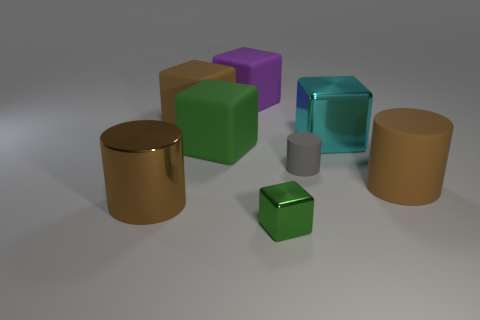Add 1 small gray matte objects. How many objects exist? 9 Subtract 5 cubes. How many cubes are left? 0 Subtract all rubber cubes. How many cubes are left? 2 Subtract all blocks. How many objects are left? 3 Add 6 small cylinders. How many small cylinders are left? 7 Add 7 matte blocks. How many matte blocks exist? 10 Subtract all brown cylinders. How many cylinders are left? 1 Subtract 0 cyan cylinders. How many objects are left? 8 Subtract all purple cubes. Subtract all gray cylinders. How many cubes are left? 4 Subtract all red cubes. How many yellow cylinders are left? 0 